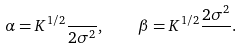Convert formula to latex. <formula><loc_0><loc_0><loc_500><loc_500>\alpha = K ^ { 1 / 2 } \frac { } { 2 \sigma ^ { 2 } } , \quad \beta = K ^ { 1 / 2 } \frac { 2 \sigma ^ { 2 } } { } .</formula> 